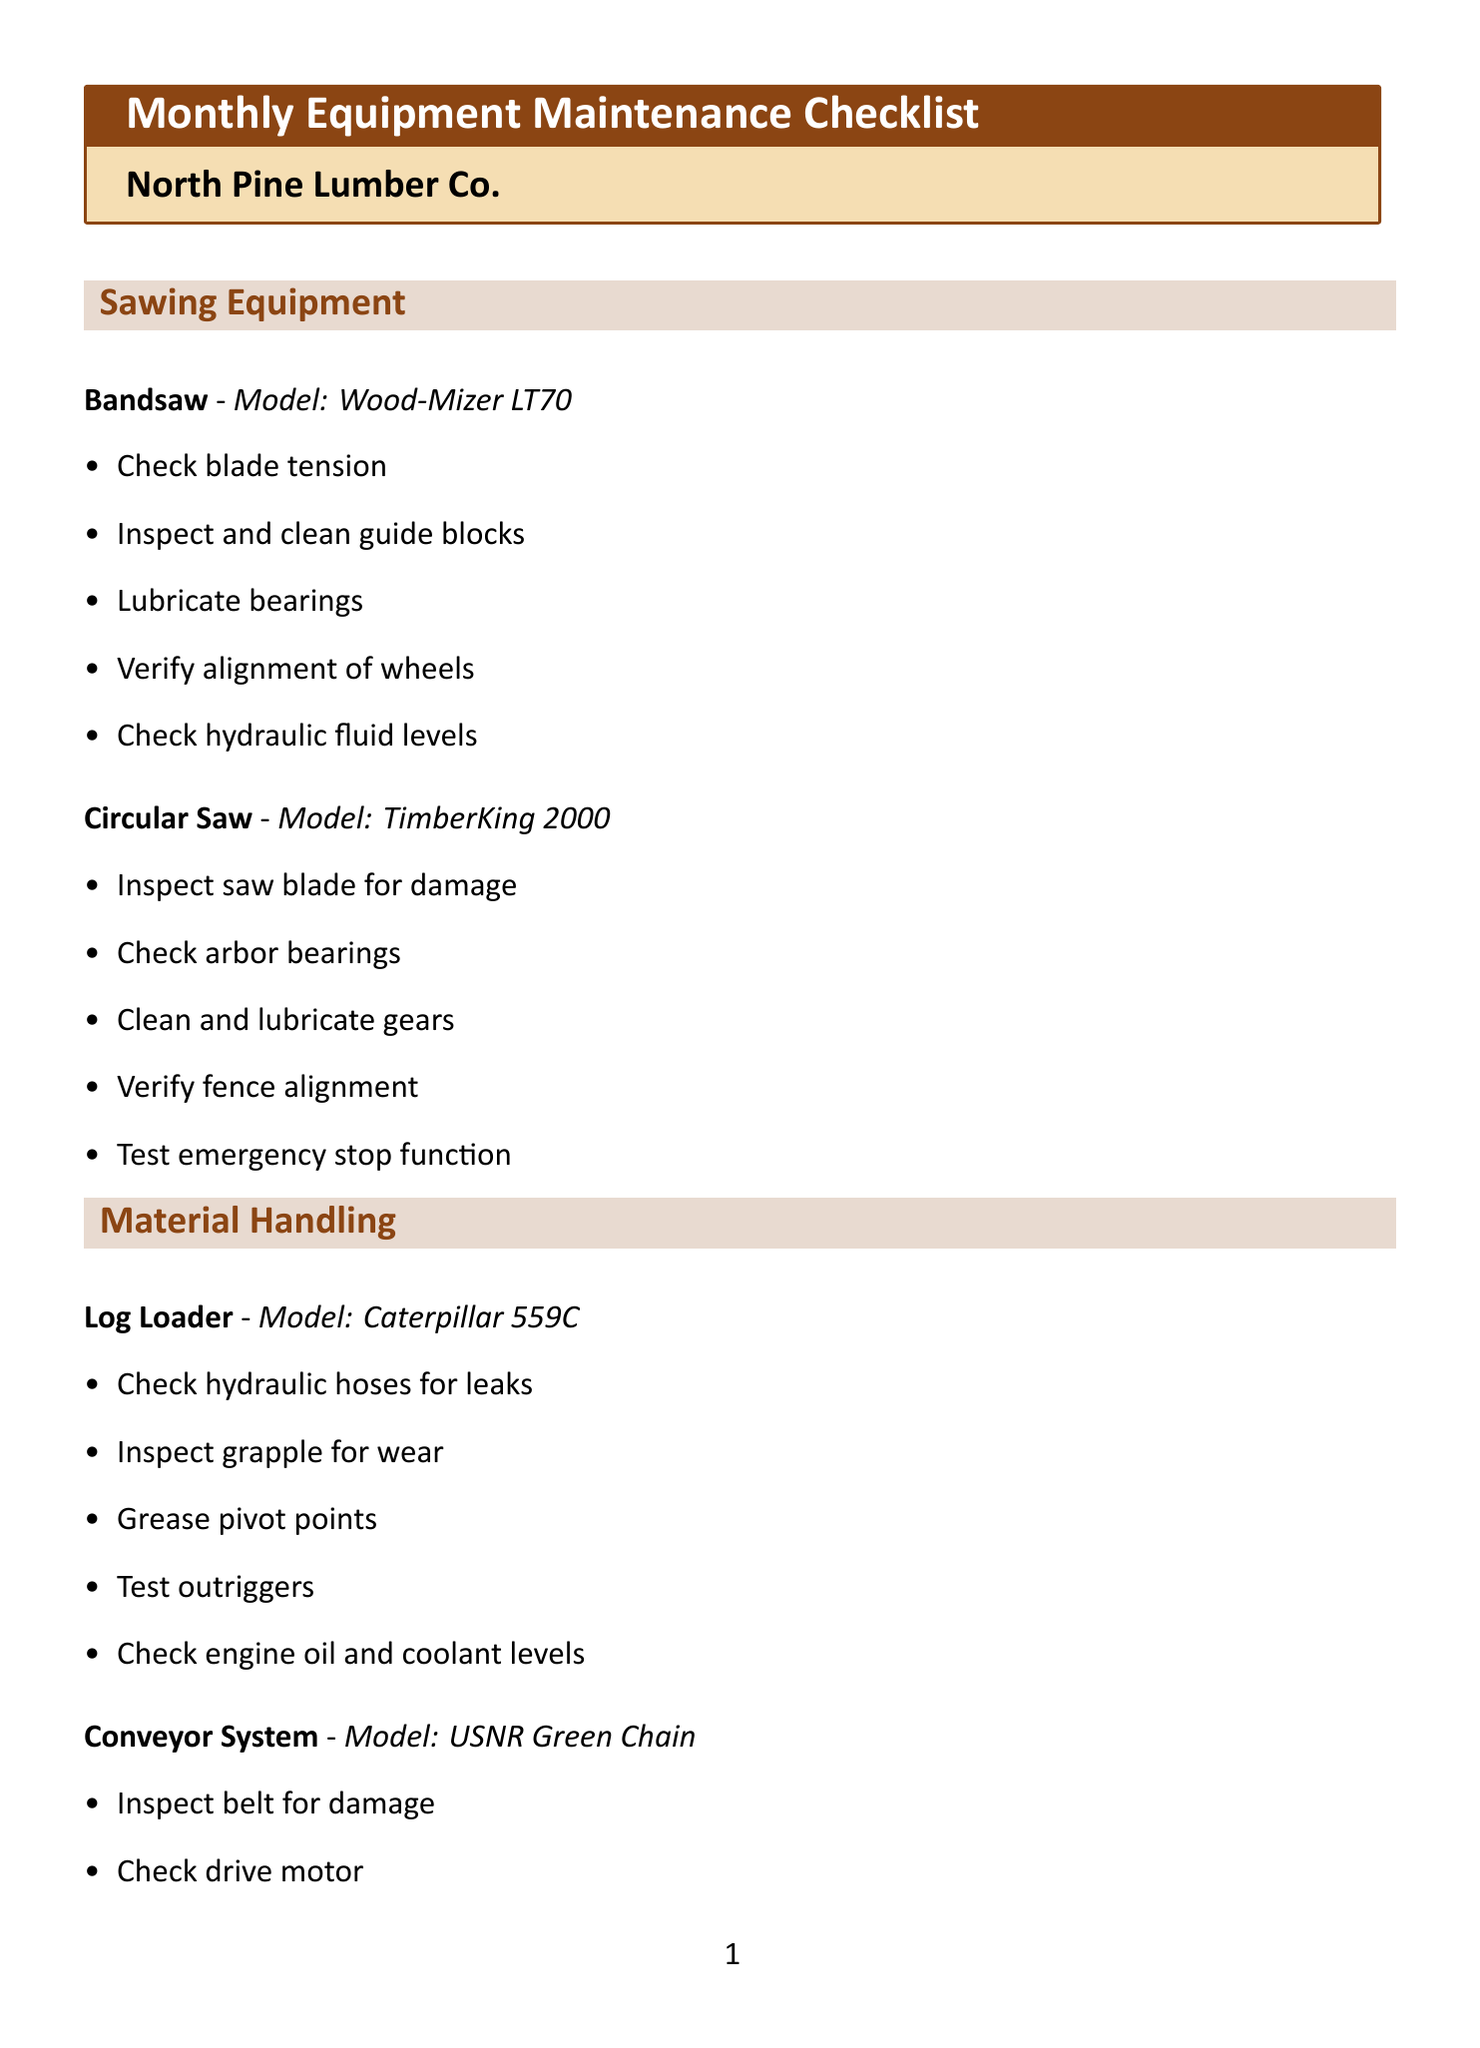What is the title of the document? The title of the document is stated at the beginning, clearly labeled as the "Monthly Equipment Maintenance Checklist."
Answer: Monthly Equipment Maintenance Checklist What is the name of the sawmill? The sawmill's name is specified prominently under the title, indicating the organization responsible for the maintenance checklist.
Answer: North Pine Lumber Co How many machines are listed under the "Sawing Equipment" section? There are two machines listed in the "Sawing Equipment" section, which includes Bandsaw and Circular Saw.
Answer: 2 What is the model name of the Log Loader? The model of the Log Loader is specified within its section, providing detailed information about the equipment being maintained.
Answer: Caterpillar 559C What task is assigned for the Kiln inspection? The tasks for the Kiln include several maintenance checks, one of which is to inspect the heating elements.
Answer: Inspect heating elements What type of equipment is the Oneida Dust Gorilla? The document delineates the various types of equipment by categorizing them; the Oneida Dust Gorilla falls under Dust Collection System.
Answer: Dust Collector Name one task listed for the Debarker. One of the tasks listed for the Debarker includes checking the hydraulic system pressure, which is crucial for its operation.
Answer: Check hydraulic system pressure What additional field requires a signature? The document outlines several fields; the one that requires a signature from the supervisor is specified at the end.
Answer: Supervisor Signature What is required to be completed before the checklist is finalized? The checklist includes a specific requirement that needs to be filled out to confirm the maintenance task's completion.
Answer: Date Completed 